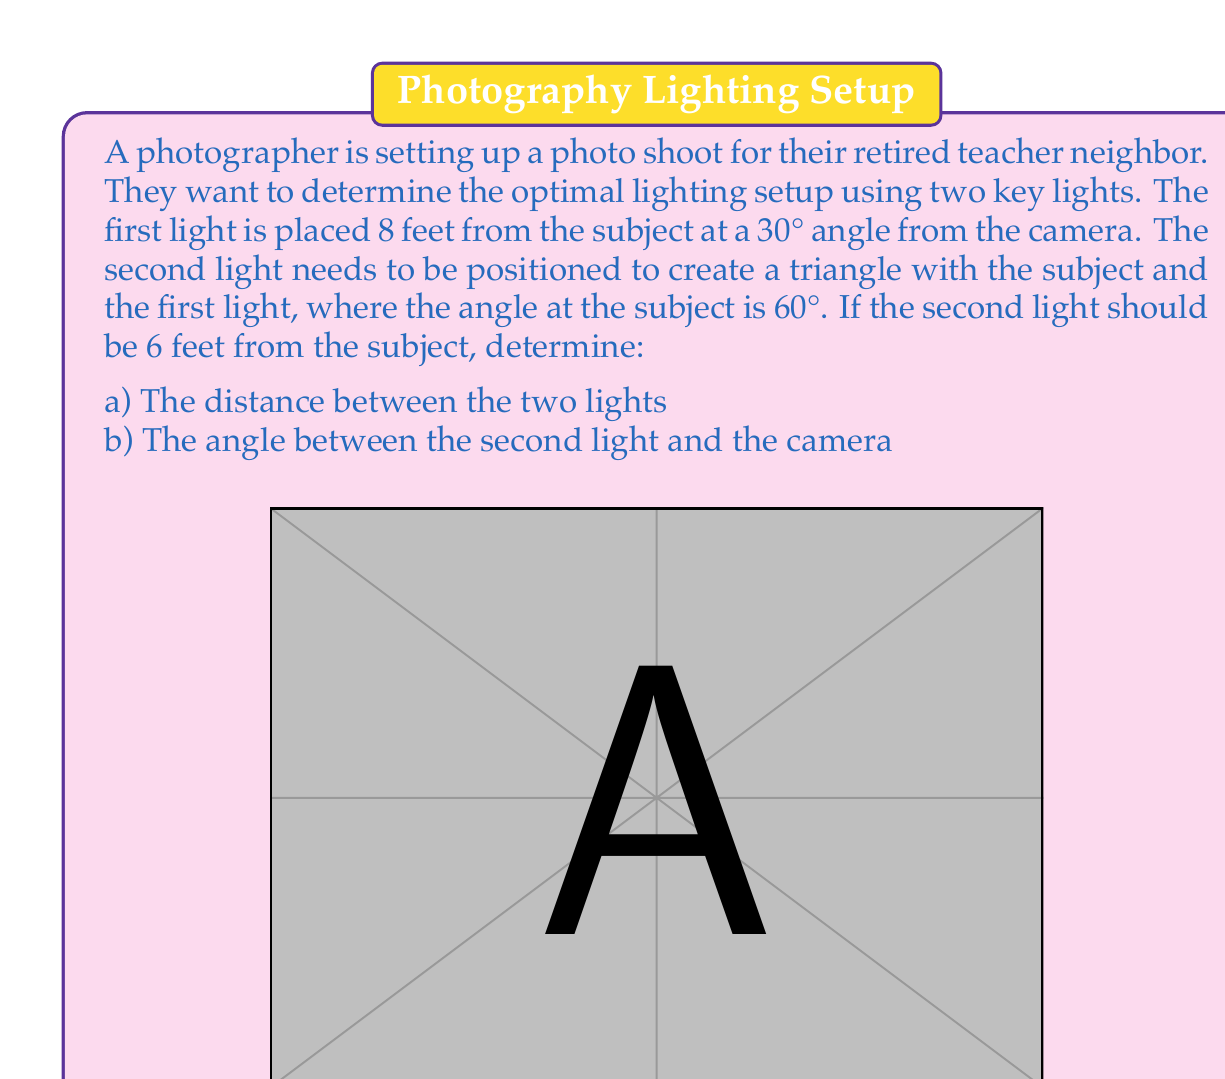Provide a solution to this math problem. Let's approach this problem step by step:

1) First, we need to find the distance between the two lights. We can do this using the law of cosines.

2) In the triangle formed by the subject and the two lights, we know:
   - Side a (subject to Light 1) = 8 ft
   - Side b (subject to Light 2) = 6 ft
   - Angle C (at the subject) = 60°

3) The law of cosines states:
   $$c^2 = a^2 + b^2 - 2ab \cos(C)$$
   where c is the distance between the lights.

4) Plugging in our values:
   $$c^2 = 8^2 + 6^2 - 2(8)(6) \cos(60°)$$
   $$c^2 = 64 + 36 - 96 \cos(60°)$$
   $$c^2 = 100 - 96(0.5)$$
   $$c^2 = 100 - 48 = 52$$
   $$c = \sqrt{52} = 2\sqrt{13} \approx 7.21 \text{ ft}$$

5) Now for the angle between the second light and the camera. We can find this using the law of sines.

6) Let's call this angle y. We know:
   - Angle A (at Light 1) = 180° - 30° - 60° = 90°
   - Side a (subject to Light 1) = 8 ft
   - Side b (subject to Light 2) = 6 ft

7) The law of sines states:
   $$\frac{\sin(A)}{a} = \frac{\sin(B)}{b} = \frac{\sin(C)}{c}$$

8) We can use this to find angle B:
   $$\frac{\sin(90°)}{8} = \frac{\sin(B)}{6}$$
   $$\sin(B) = \frac{6}{8} = 0.75$$
   $$B = \arcsin(0.75) \approx 48.59°$$

9) The angle y is then:
   $$y = 180° - 30° - 48.59° = 101.41°$$
Answer: a) The distance between the two lights is $2\sqrt{13}$ feet (approximately 7.21 feet).
b) The angle between the second light and the camera is approximately 101.41°. 